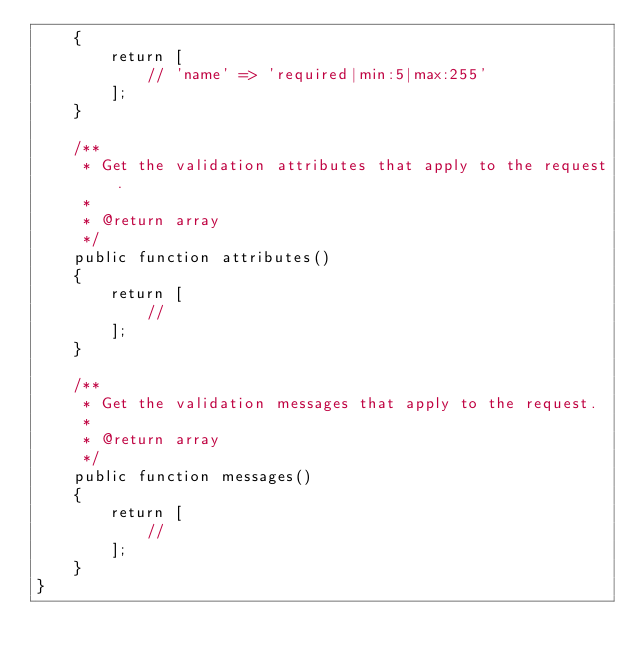<code> <loc_0><loc_0><loc_500><loc_500><_PHP_>    {
        return [
            // 'name' => 'required|min:5|max:255'
        ];
    }

    /**
     * Get the validation attributes that apply to the request.
     *
     * @return array
     */
    public function attributes()
    {
        return [
            //
        ];
    }

    /**
     * Get the validation messages that apply to the request.
     *
     * @return array
     */
    public function messages()
    {
        return [
            //
        ];
    }
}
</code> 